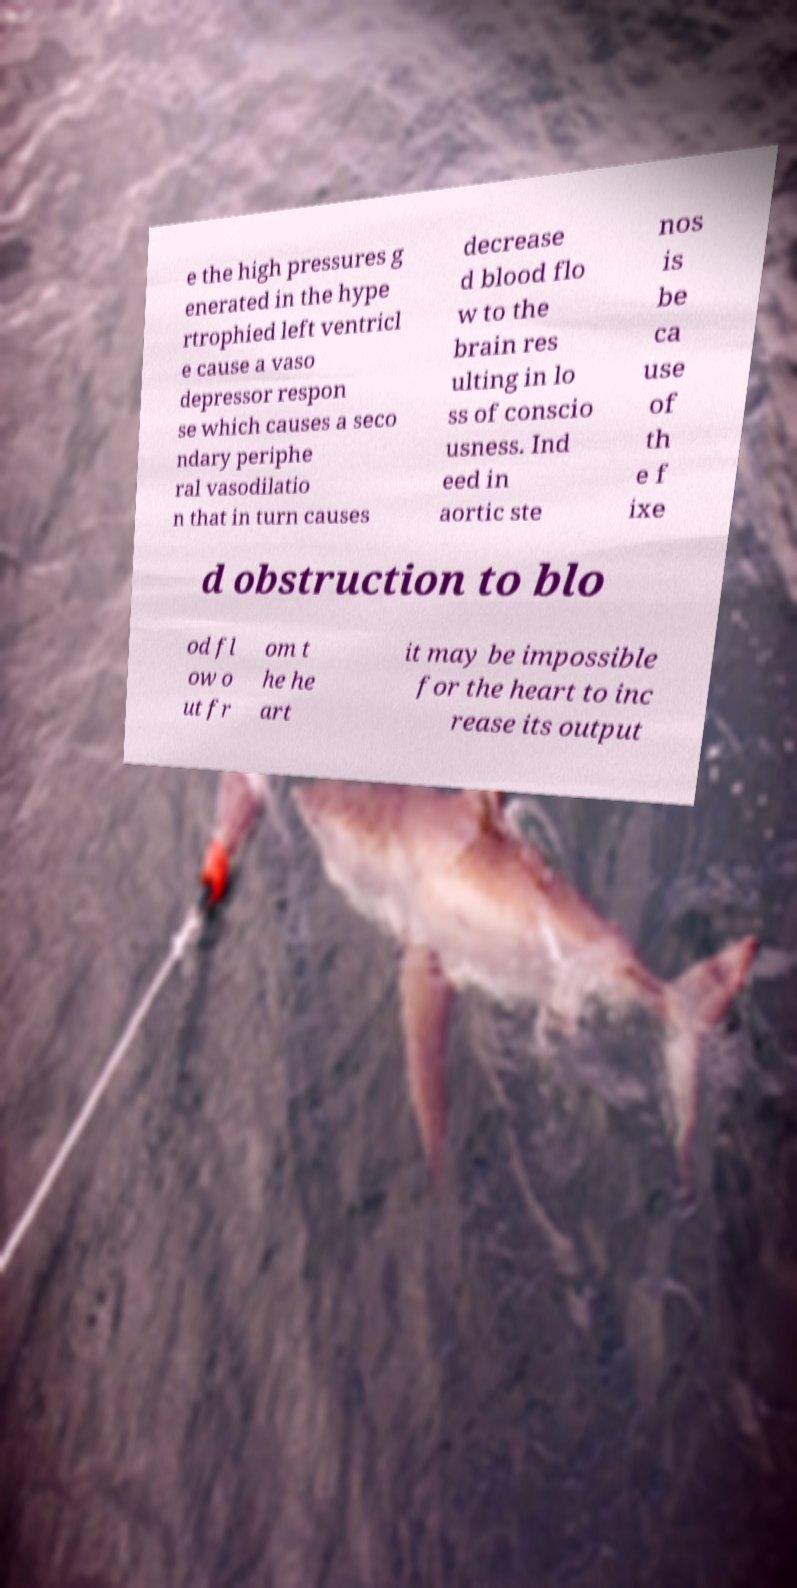There's text embedded in this image that I need extracted. Can you transcribe it verbatim? e the high pressures g enerated in the hype rtrophied left ventricl e cause a vaso depressor respon se which causes a seco ndary periphe ral vasodilatio n that in turn causes decrease d blood flo w to the brain res ulting in lo ss of conscio usness. Ind eed in aortic ste nos is be ca use of th e f ixe d obstruction to blo od fl ow o ut fr om t he he art it may be impossible for the heart to inc rease its output 